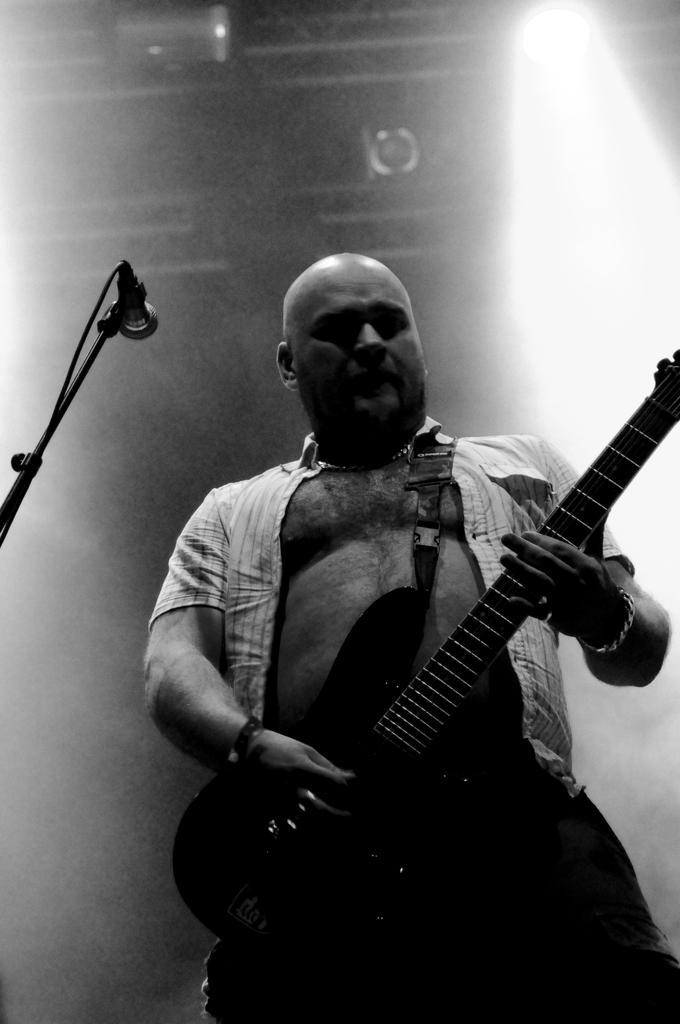Please provide a concise description of this image. In this image man is standing and holding a guitar in his hand. On the left side there is a Mic. In the background there is a wall. 